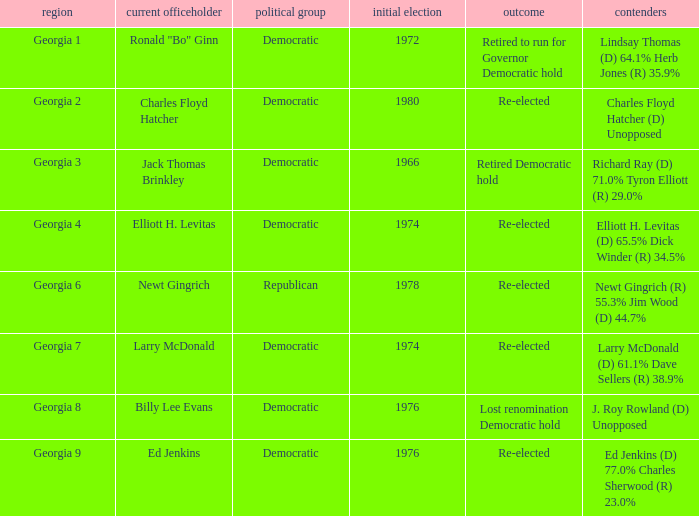Can you parse all the data within this table? {'header': ['region', 'current officeholder', 'political group', 'initial election', 'outcome', 'contenders'], 'rows': [['Georgia 1', 'Ronald "Bo" Ginn', 'Democratic', '1972', 'Retired to run for Governor Democratic hold', 'Lindsay Thomas (D) 64.1% Herb Jones (R) 35.9%'], ['Georgia 2', 'Charles Floyd Hatcher', 'Democratic', '1980', 'Re-elected', 'Charles Floyd Hatcher (D) Unopposed'], ['Georgia 3', 'Jack Thomas Brinkley', 'Democratic', '1966', 'Retired Democratic hold', 'Richard Ray (D) 71.0% Tyron Elliott (R) 29.0%'], ['Georgia 4', 'Elliott H. Levitas', 'Democratic', '1974', 'Re-elected', 'Elliott H. Levitas (D) 65.5% Dick Winder (R) 34.5%'], ['Georgia 6', 'Newt Gingrich', 'Republican', '1978', 'Re-elected', 'Newt Gingrich (R) 55.3% Jim Wood (D) 44.7%'], ['Georgia 7', 'Larry McDonald', 'Democratic', '1974', 'Re-elected', 'Larry McDonald (D) 61.1% Dave Sellers (R) 38.9%'], ['Georgia 8', 'Billy Lee Evans', 'Democratic', '1976', 'Lost renomination Democratic hold', 'J. Roy Rowland (D) Unopposed'], ['Georgia 9', 'Ed Jenkins', 'Democratic', '1976', 'Re-elected', 'Ed Jenkins (D) 77.0% Charles Sherwood (R) 23.0%']]} Name the party for jack thomas brinkley Democratic. 